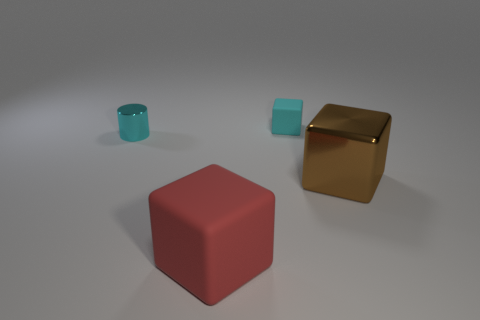Add 1 green shiny cubes. How many objects exist? 5 Subtract all blocks. How many objects are left? 1 Add 2 big cubes. How many big cubes are left? 4 Add 3 small gray metal cylinders. How many small gray metal cylinders exist? 3 Subtract 0 brown balls. How many objects are left? 4 Subtract all small things. Subtract all red rubber cubes. How many objects are left? 1 